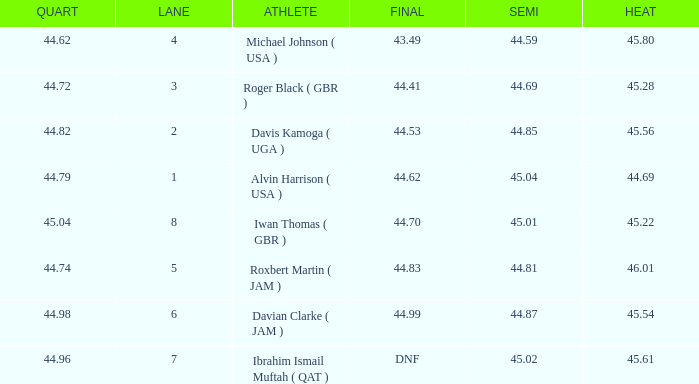When a lane of 4 has a QUART greater than 44.62, what is the lowest HEAT? None. 